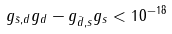Convert formula to latex. <formula><loc_0><loc_0><loc_500><loc_500>g _ { \bar { s } , d } g _ { d } - g _ { \bar { d } , s } g _ { s } < 1 0 ^ { - 1 8 }</formula> 